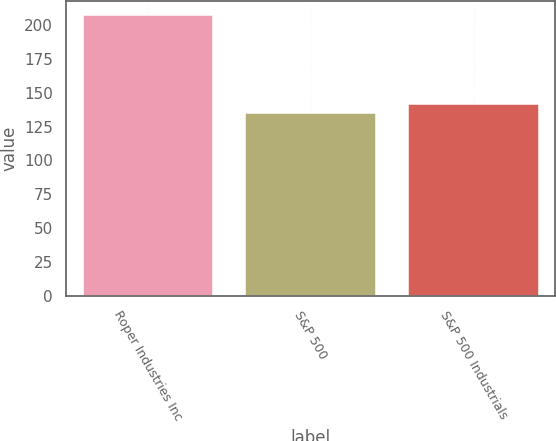Convert chart to OTSL. <chart><loc_0><loc_0><loc_500><loc_500><bar_chart><fcel>Roper Industries Inc<fcel>S&P 500<fcel>S&P 500 Industrials<nl><fcel>207.35<fcel>134.7<fcel>141.96<nl></chart> 